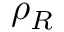<formula> <loc_0><loc_0><loc_500><loc_500>\rho _ { R }</formula> 